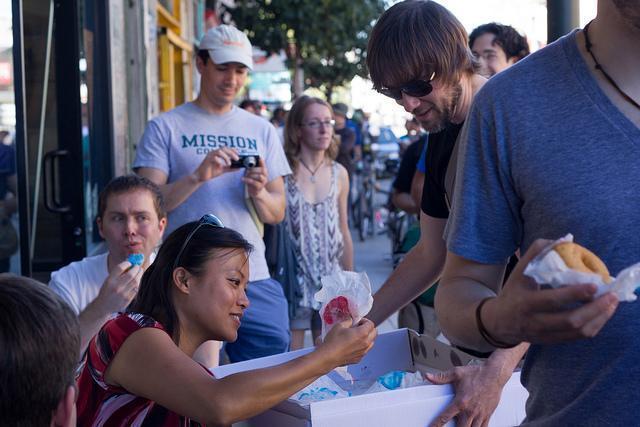What is the man wearing a hat doing with the camera?
Select the accurate answer and provide explanation: 'Answer: answer
Rationale: rationale.'
Options: Throwing it, selling it, taking pictures, buying it. Answer: taking pictures.
Rationale: The man is snapping photos. 